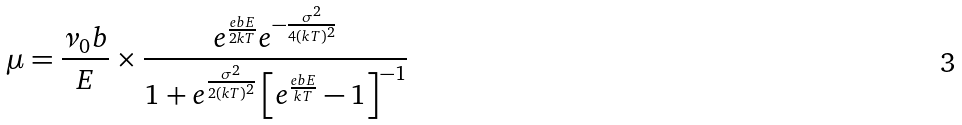<formula> <loc_0><loc_0><loc_500><loc_500>\mu = \frac { \nu _ { 0 } b } { E } \times \frac { e ^ { \frac { e b E } { 2 k T } } e ^ { - \frac { \sigma ^ { 2 } } { 4 ( k T ) ^ { 2 } } } } { 1 + e ^ { \frac { \sigma ^ { 2 } } { 2 ( k T ) ^ { 2 } } } \left [ e ^ { \frac { e b E } { k T } } - 1 \right ] ^ { - 1 } }</formula> 